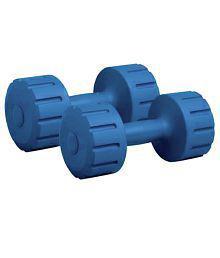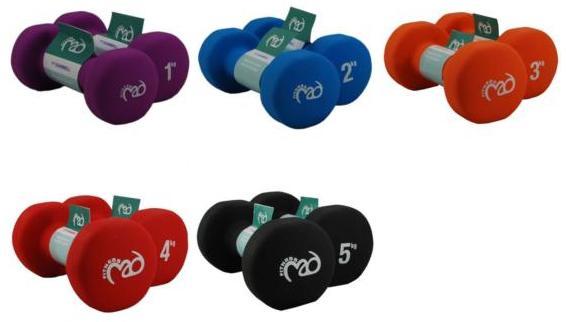The first image is the image on the left, the second image is the image on the right. For the images shown, is this caption "In the image to the right, there is only one pair of free weights." true? Answer yes or no. No. The first image is the image on the left, the second image is the image on the right. Analyze the images presented: Is the assertion "There are two blue dumbbells." valid? Answer yes or no. No. 